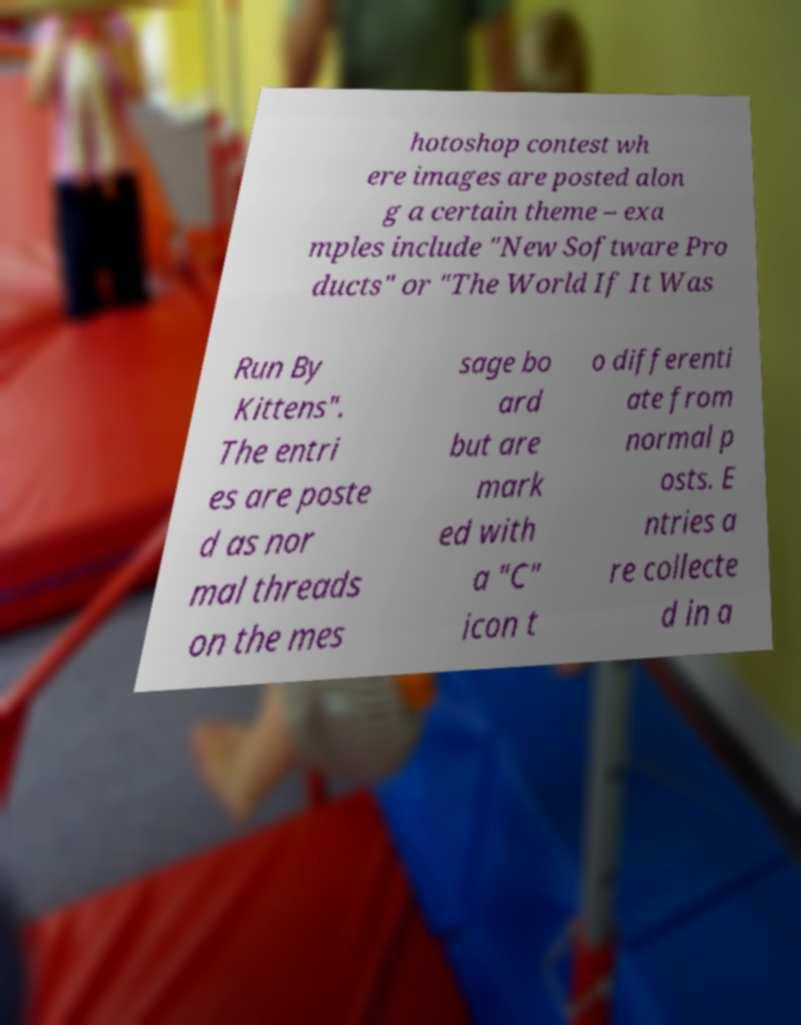Could you extract and type out the text from this image? hotoshop contest wh ere images are posted alon g a certain theme – exa mples include "New Software Pro ducts" or "The World If It Was Run By Kittens". The entri es are poste d as nor mal threads on the mes sage bo ard but are mark ed with a "C" icon t o differenti ate from normal p osts. E ntries a re collecte d in a 